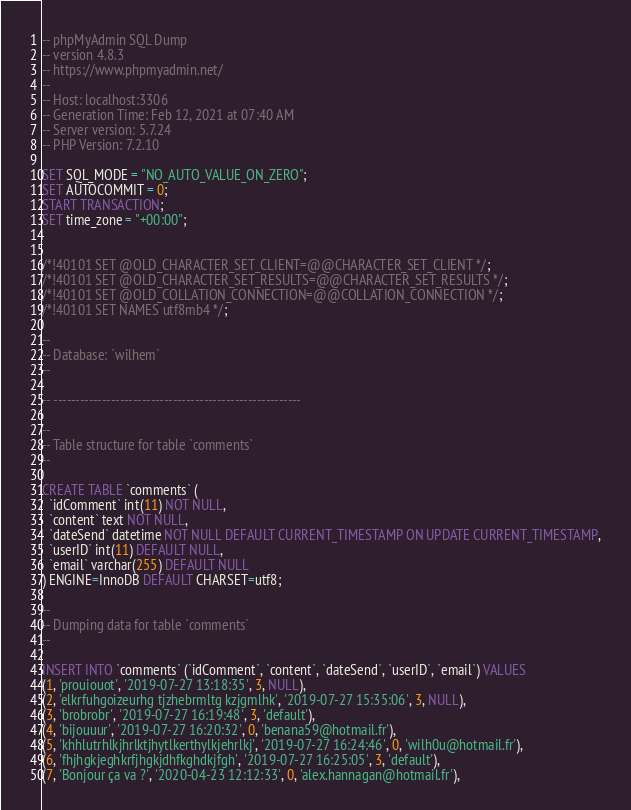<code> <loc_0><loc_0><loc_500><loc_500><_SQL_>-- phpMyAdmin SQL Dump
-- version 4.8.3
-- https://www.phpmyadmin.net/
--
-- Host: localhost:3306
-- Generation Time: Feb 12, 2021 at 07:40 AM
-- Server version: 5.7.24
-- PHP Version: 7.2.10

SET SQL_MODE = "NO_AUTO_VALUE_ON_ZERO";
SET AUTOCOMMIT = 0;
START TRANSACTION;
SET time_zone = "+00:00";


/*!40101 SET @OLD_CHARACTER_SET_CLIENT=@@CHARACTER_SET_CLIENT */;
/*!40101 SET @OLD_CHARACTER_SET_RESULTS=@@CHARACTER_SET_RESULTS */;
/*!40101 SET @OLD_COLLATION_CONNECTION=@@COLLATION_CONNECTION */;
/*!40101 SET NAMES utf8mb4 */;

--
-- Database: `wilhem`
--

-- --------------------------------------------------------

--
-- Table structure for table `comments`
--

CREATE TABLE `comments` (
  `idComment` int(11) NOT NULL,
  `content` text NOT NULL,
  `dateSend` datetime NOT NULL DEFAULT CURRENT_TIMESTAMP ON UPDATE CURRENT_TIMESTAMP,
  `userID` int(11) DEFAULT NULL,
  `email` varchar(255) DEFAULT NULL
) ENGINE=InnoDB DEFAULT CHARSET=utf8;

--
-- Dumping data for table `comments`
--

INSERT INTO `comments` (`idComment`, `content`, `dateSend`, `userID`, `email`) VALUES
(1, 'prouiouot', '2019-07-27 13:18:35', 3, NULL),
(2, 'elkrfuhgoizeurhg tjzhebrmltg kzjgmlhk', '2019-07-27 15:35:06', 3, NULL),
(3, 'brobrobr', '2019-07-27 16:19:48', 3, 'default'),
(4, 'bijouuur', '2019-07-27 16:20:32', 0, 'benana59@hotmail.fr'),
(5, 'khhlutrhlkjhrlktjhytlkerthylkjehrlkj', '2019-07-27 16:24:46', 0, 'wilh0u@hotmail.fr'),
(6, 'fhjhgkjeghkrfjhgkjdhfkghdkjfgh', '2019-07-27 16:25:05', 3, 'default'),
(7, 'Bonjour ça va ?', '2020-04-23 12:12:33', 0, 'alex.hannagan@hotmail.fr'),</code> 